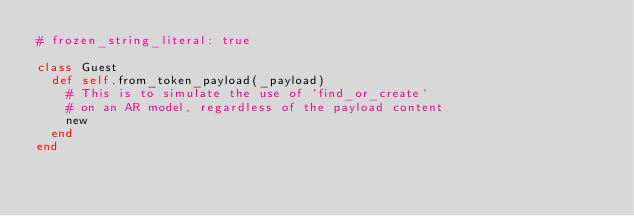<code> <loc_0><loc_0><loc_500><loc_500><_Ruby_># frozen_string_literal: true

class Guest
  def self.from_token_payload(_payload)
    # This is to simulate the use of `find_or_create`
    # on an AR model, regardless of the payload content
    new
  end
end
</code> 